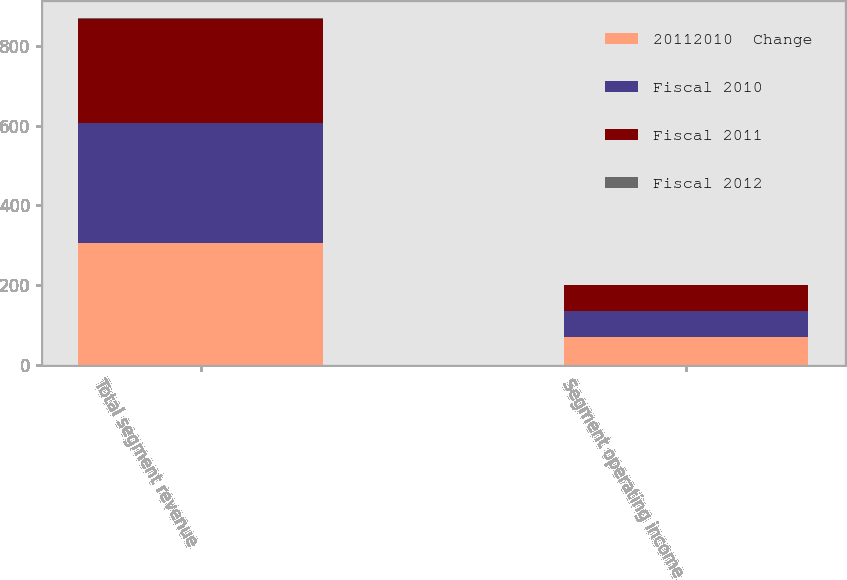Convert chart. <chart><loc_0><loc_0><loc_500><loc_500><stacked_bar_chart><ecel><fcel>Total segment revenue<fcel>Segment operating income<nl><fcel>20112010  Change<fcel>305<fcel>68<nl><fcel>Fiscal 2010<fcel>302<fcel>67<nl><fcel>Fiscal 2011<fcel>262<fcel>64<nl><fcel>Fiscal 2012<fcel>1<fcel>1<nl></chart> 